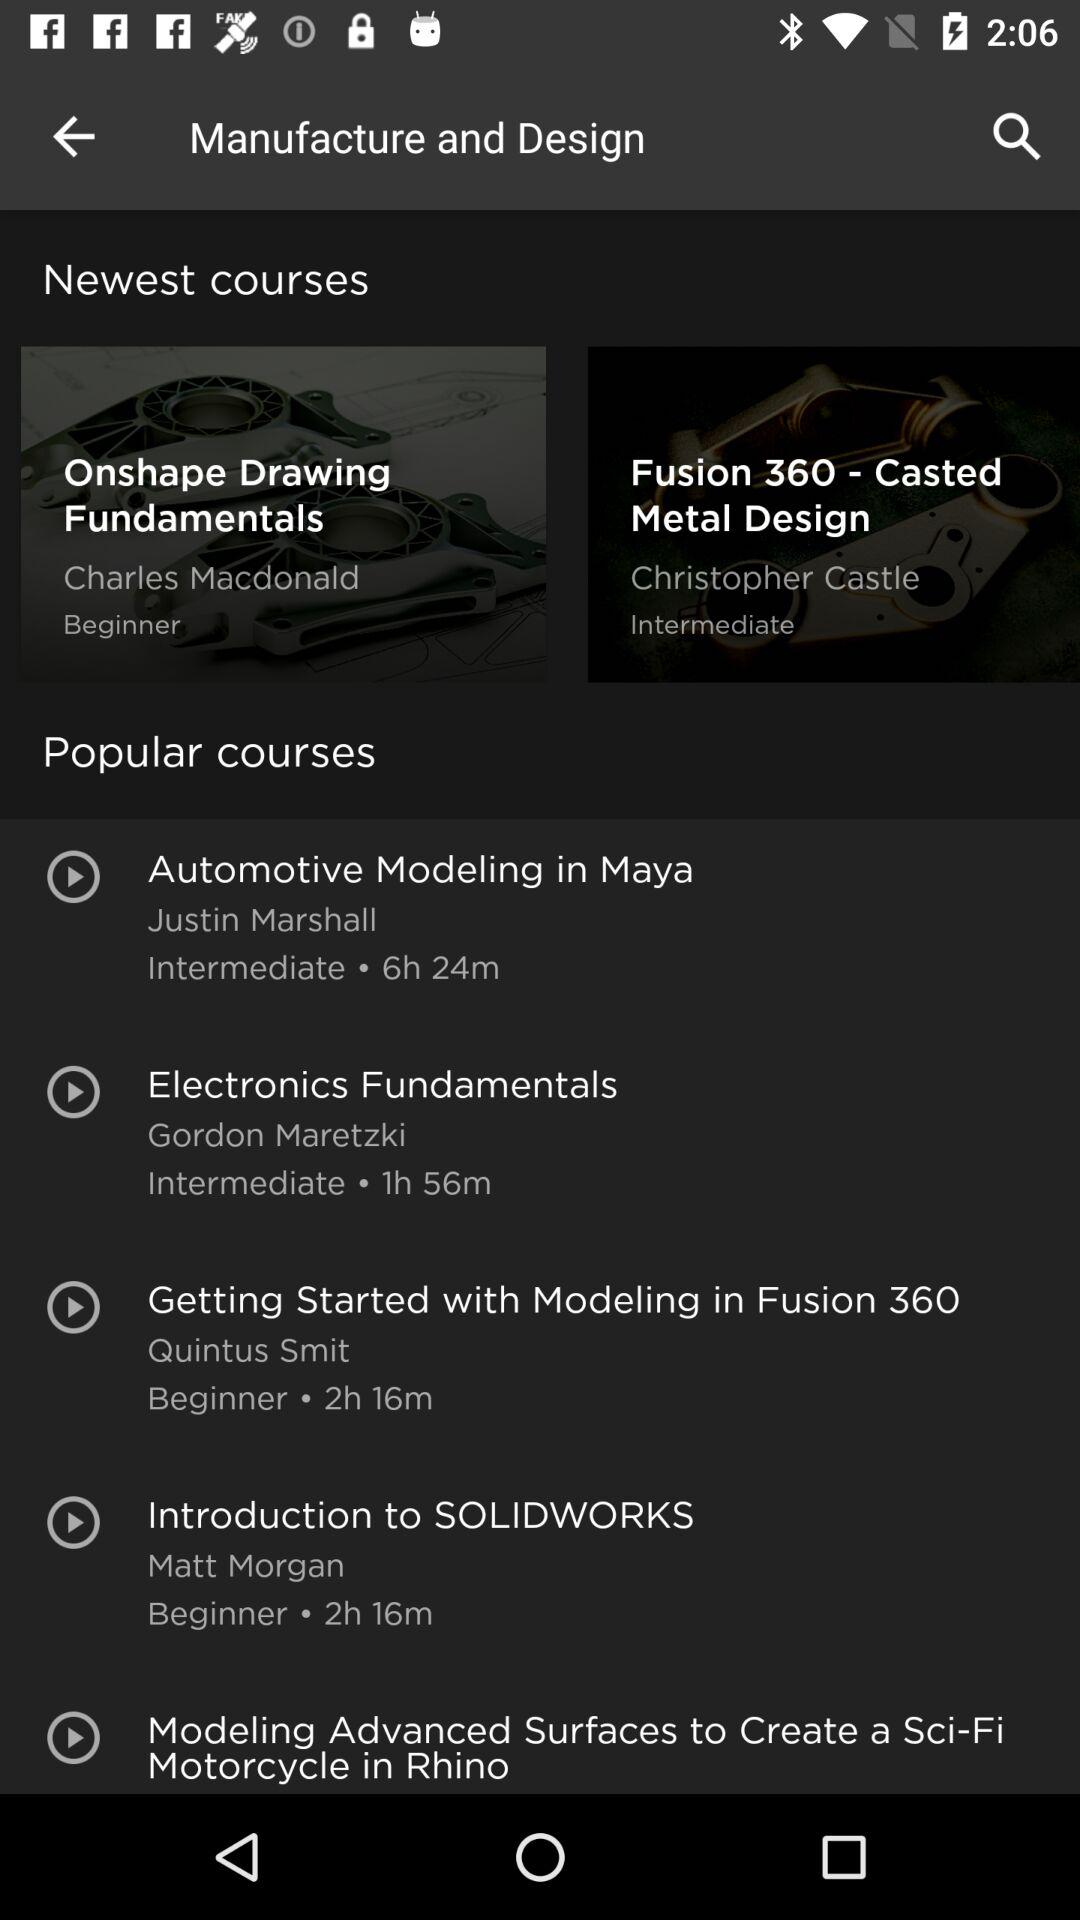What's the duration of the "Introduction to SOLIDWORKS"? The duration is 2 hours 16 minutes. 